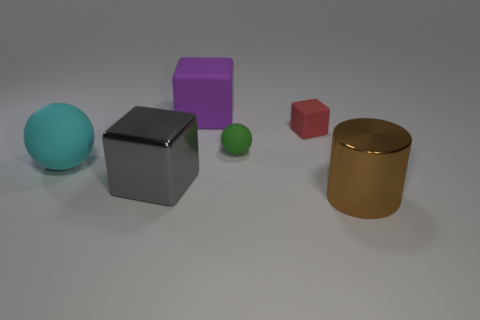Do the big rubber cube and the large sphere have the same color? no 